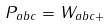Convert formula to latex. <formula><loc_0><loc_0><loc_500><loc_500>P _ { a b c } = W _ { a b c + }</formula> 